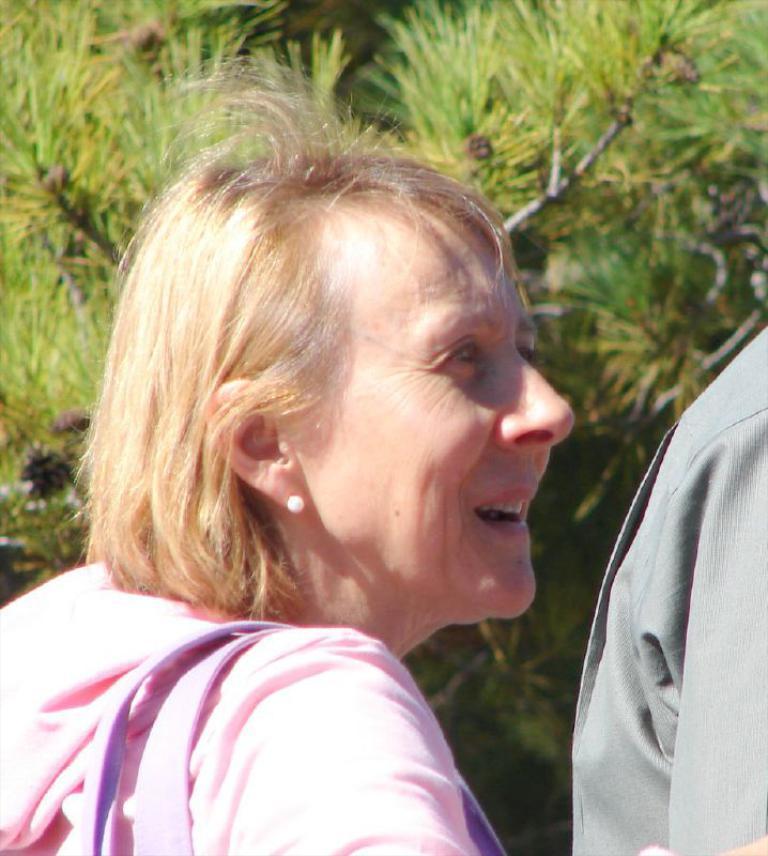How would you summarize this image in a sentence or two? In this picture I can see a woman and another human on the right side and I can see tree in the back. 